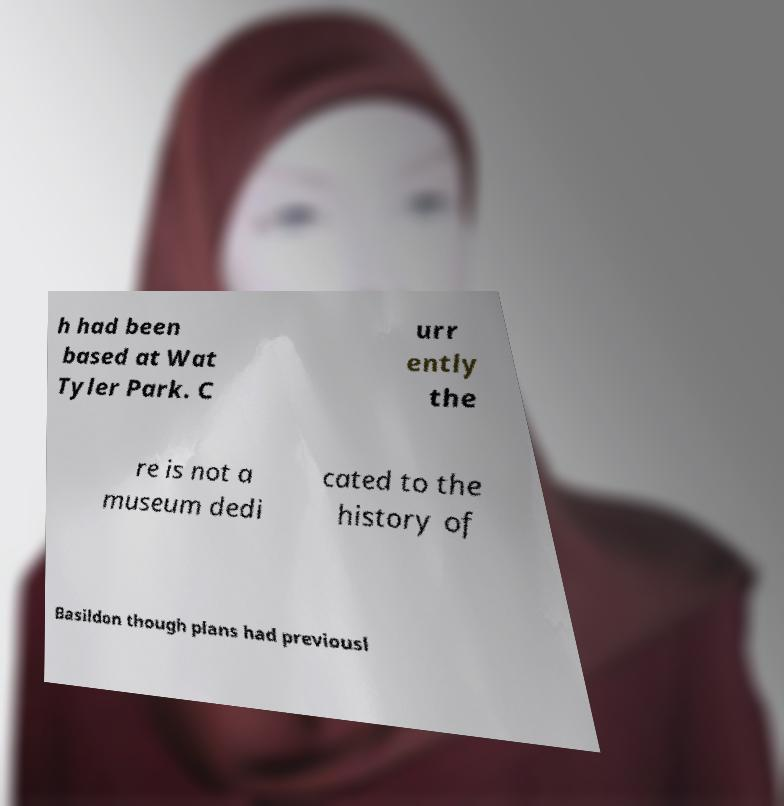Could you extract and type out the text from this image? h had been based at Wat Tyler Park. C urr ently the re is not a museum dedi cated to the history of Basildon though plans had previousl 